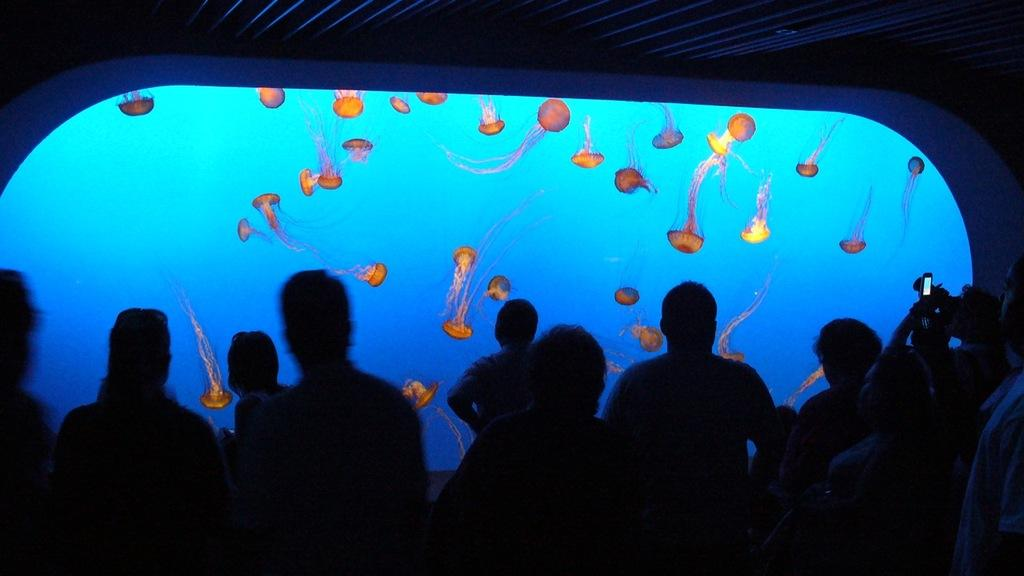Who or what is present in the image? There are people in the image. What can be seen in the background of the image? There are aquatic animals in the background of the image. Where are the aquatic animals located? The aquatic animals are in the water. What type of book is being used as a prop in the image? There is no book present in the image. 